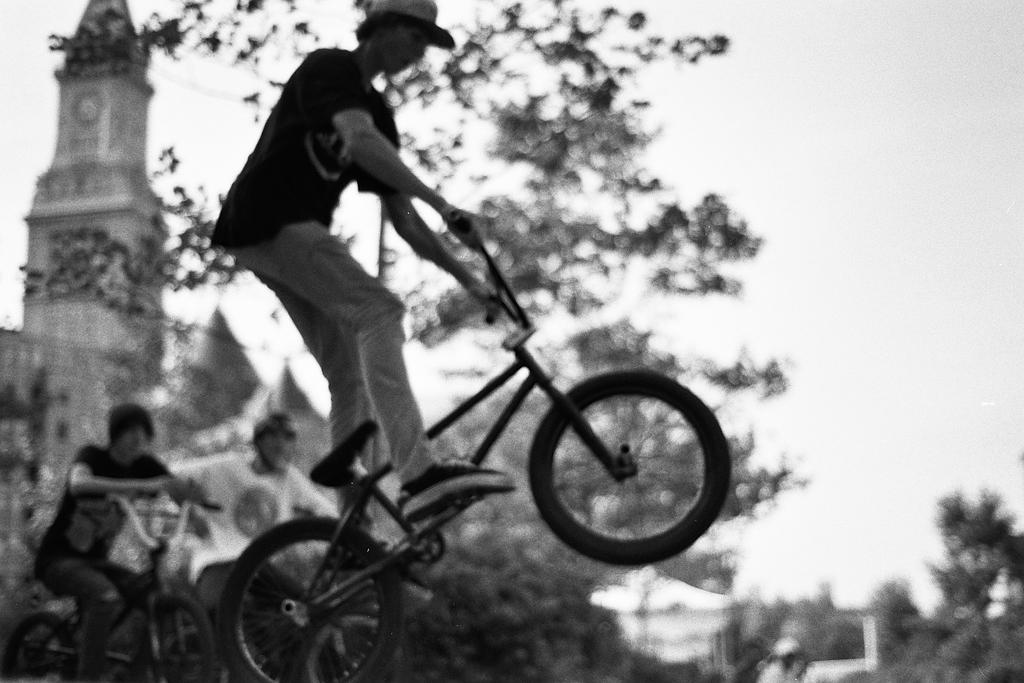What is the main subject of the image? The main subject of the image is a boy on a bicycle. What is the boy doing on the bicycle? The boy is doing stunts on the bicycle. Are there any other people on bicycles in the image? Yes, there are two boys on bicycles in the background. What can be seen in the background of the image? There is a church, trees, and the sky visible in the background. How does the boy answer the question about transportation in the image? There is no indication in the image that the boy is answering a question about transportation. 